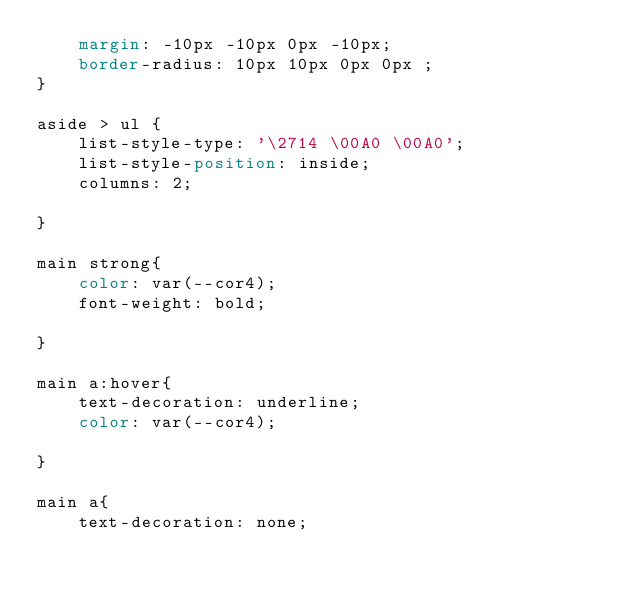Convert code to text. <code><loc_0><loc_0><loc_500><loc_500><_CSS_>    margin: -10px -10px 0px -10px;
    border-radius: 10px 10px 0px 0px ;
}

aside > ul {
    list-style-type: '\2714 \00A0 \00A0';
    list-style-position: inside;
    columns: 2;
   
}

main strong{
    color: var(--cor4);
    font-weight: bold;
   
}

main a:hover{
    text-decoration: underline;
    color: var(--cor4);

}

main a{
    text-decoration: none;</code> 